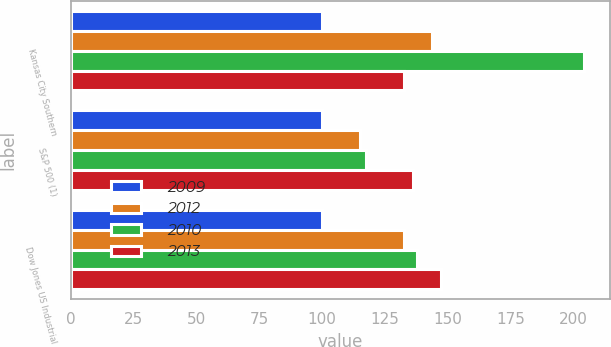Convert chart to OTSL. <chart><loc_0><loc_0><loc_500><loc_500><stacked_bar_chart><ecel><fcel>Kansas City Southern<fcel>S&P 500 (1)<fcel>Dow Jones US Industrial<nl><fcel>2009<fcel>100<fcel>100<fcel>100<nl><fcel>2012<fcel>143.77<fcel>115.06<fcel>132.77<nl><fcel>2010<fcel>204.3<fcel>117.49<fcel>137.94<nl><fcel>2013<fcel>132.77<fcel>136.3<fcel>147.4<nl></chart> 